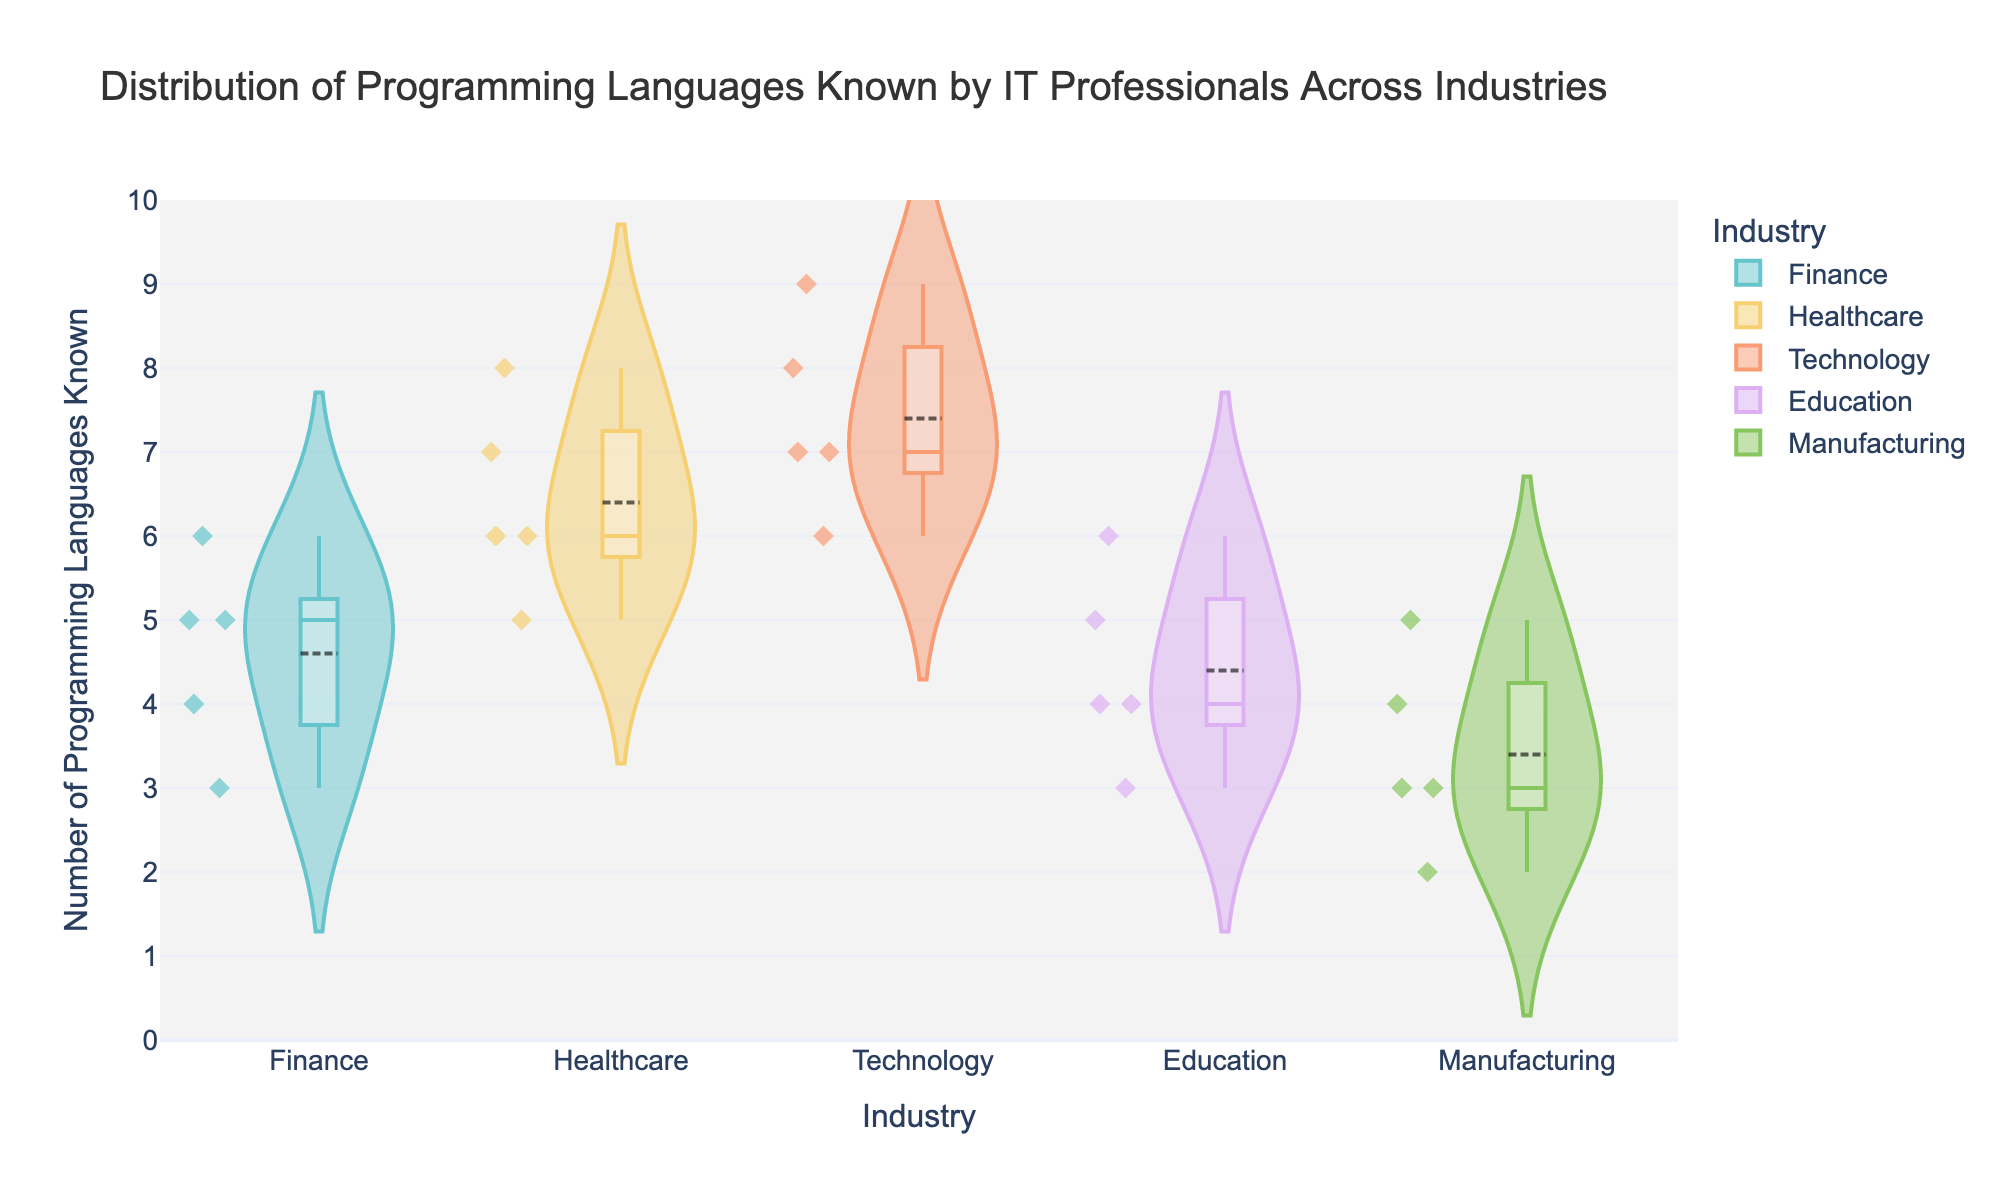What's the title of the figure? The title is typically displayed at the top of the figure and summarizes the content or purpose of the chart.
Answer: Distribution of Programming Languages Known by IT Professionals Across Industries Which industry has IT professionals knowing the greatest number of programming languages? Examine the top ends of each violin plot to identify the highest value. The Technology industry has the highest point at 9.
Answer: Technology Which industry has the smallest range in the number of programming languages known by IT professionals? Look at the height and spread of each violin plot to determine the range. Education ranges from 3 to 6, which is the smallest range.
Answer: Education What's the median number of programming languages known by IT professionals in the Healthcare industry? The median value is the center line of the box within the violin plot. For Healthcare, this line is at 6.
Answer: 6 Which industry has the most data points for the number of programming languages known by IT professionals? Data points are shown as individual dots within the violin plot. Count the dots in each category. Healthcare and Technology both have 5 data points.
Answer: Healthcare and Technology How does the mean number of programming languages known by IT professionals in Finance compare to Technology? The mean is indicated by the mean line within each violin plot. In Finance, the mean is around 4.6, whereas in Technology, it is approximately 7.
Answer: Technology has a higher mean Which industry has the widest distribution of programming languages known by IT professionals? The widest distribution is seen in the most spread-out violin plot. Manufacturing ranges from 2 to 5, indicating a wide distribution.
Answer: Manufacturing What is the most common number of programming languages known by IT professionals in the Finance industry? The mode is the highest density point in the violin plot. In Finance, the most common number is 5.
Answer: 5 